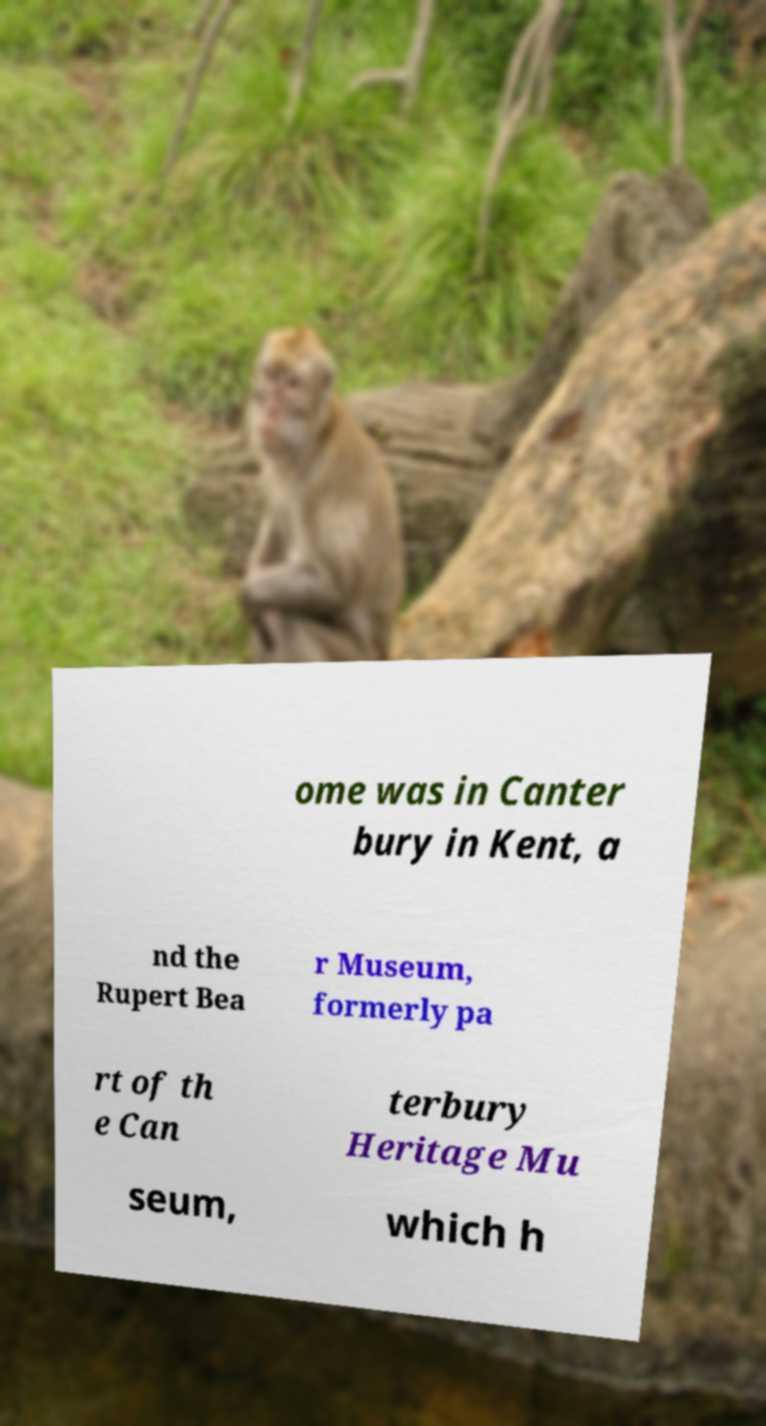Please identify and transcribe the text found in this image. ome was in Canter bury in Kent, a nd the Rupert Bea r Museum, formerly pa rt of th e Can terbury Heritage Mu seum, which h 